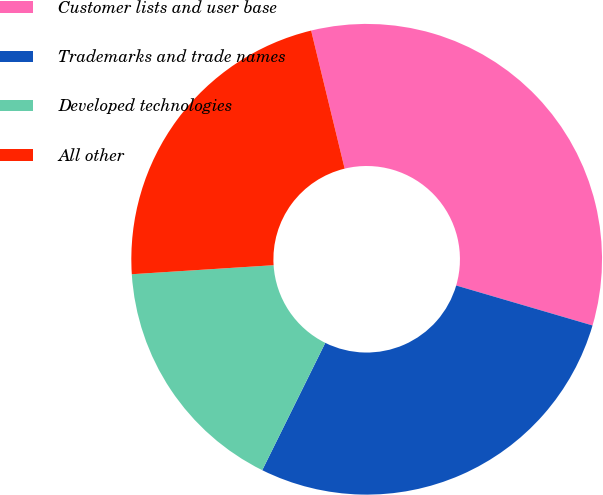Convert chart to OTSL. <chart><loc_0><loc_0><loc_500><loc_500><pie_chart><fcel>Customer lists and user base<fcel>Trademarks and trade names<fcel>Developed technologies<fcel>All other<nl><fcel>33.33%<fcel>27.78%<fcel>16.67%<fcel>22.22%<nl></chart> 